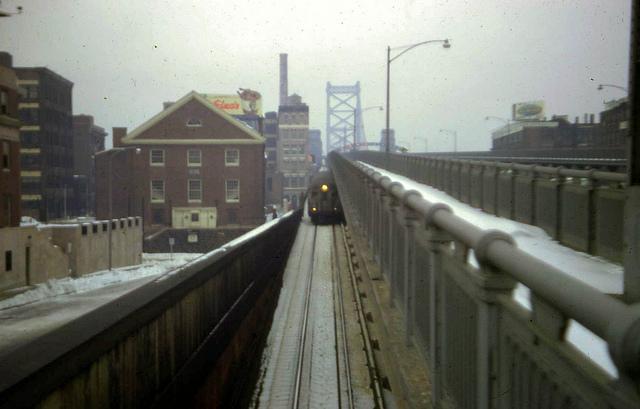How many lamp posts are in this picture?
Keep it brief. 2. Is the light on the train?
Keep it brief. Yes. How is the sky?
Answer briefly. Overcast. 